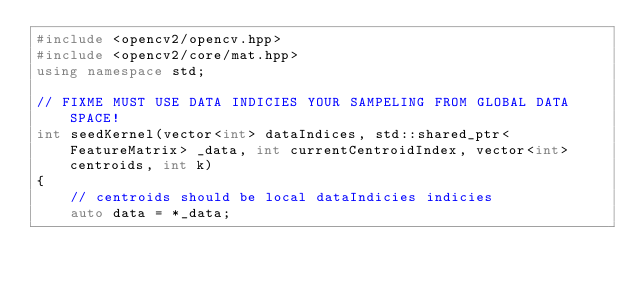<code> <loc_0><loc_0><loc_500><loc_500><_C++_>#include <opencv2/opencv.hpp>
#include <opencv2/core/mat.hpp>
using namespace std;

// FIXME MUST USE DATA INDICIES YOUR SAMPELING FROM GLOBAL DATA SPACE!
int seedKernel(vector<int> dataIndices, std::shared_ptr<FeatureMatrix> _data, int currentCentroidIndex, vector<int> centroids, int k)
{
    // centroids should be local dataIndicies indicies
    auto data = *_data;</code> 